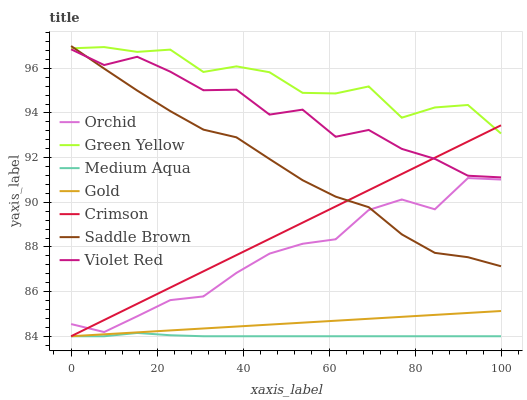Does Medium Aqua have the minimum area under the curve?
Answer yes or no. Yes. Does Green Yellow have the maximum area under the curve?
Answer yes or no. Yes. Does Gold have the minimum area under the curve?
Answer yes or no. No. Does Gold have the maximum area under the curve?
Answer yes or no. No. Is Gold the smoothest?
Answer yes or no. Yes. Is Violet Red the roughest?
Answer yes or no. Yes. Is Medium Aqua the smoothest?
Answer yes or no. No. Is Medium Aqua the roughest?
Answer yes or no. No. Does Gold have the lowest value?
Answer yes or no. Yes. Does Green Yellow have the lowest value?
Answer yes or no. No. Does Saddle Brown have the highest value?
Answer yes or no. Yes. Does Gold have the highest value?
Answer yes or no. No. Is Violet Red less than Green Yellow?
Answer yes or no. Yes. Is Green Yellow greater than Orchid?
Answer yes or no. Yes. Does Saddle Brown intersect Orchid?
Answer yes or no. Yes. Is Saddle Brown less than Orchid?
Answer yes or no. No. Is Saddle Brown greater than Orchid?
Answer yes or no. No. Does Violet Red intersect Green Yellow?
Answer yes or no. No. 